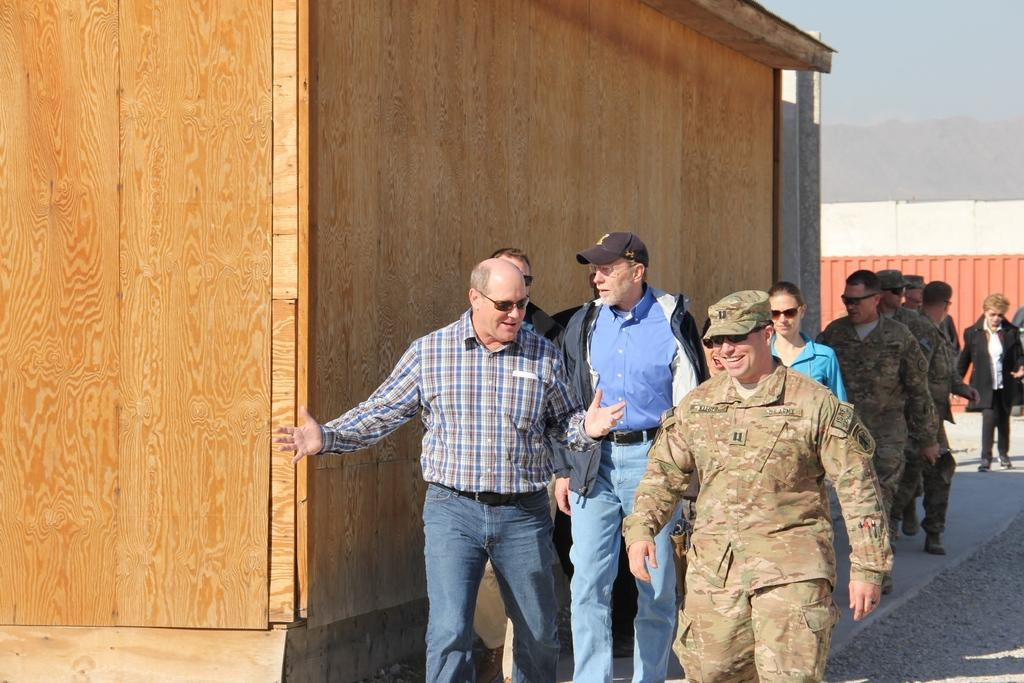What are the persons in the image doing? The persons in the image are walking on the ground. What type of structure is near the scene? The scene takes place near a wooden house. What can be seen in the background of the image? There is a vehicle and an unspecified object in the background of the image. What is visible above the scene? The sky is visible in the background of the image. What type of thread is being used to create the station in the image? There is no station or thread present in the image. How does the unspecified object in the background shake in the image? The unspecified object in the background does not shake in the image; it is stationary. 